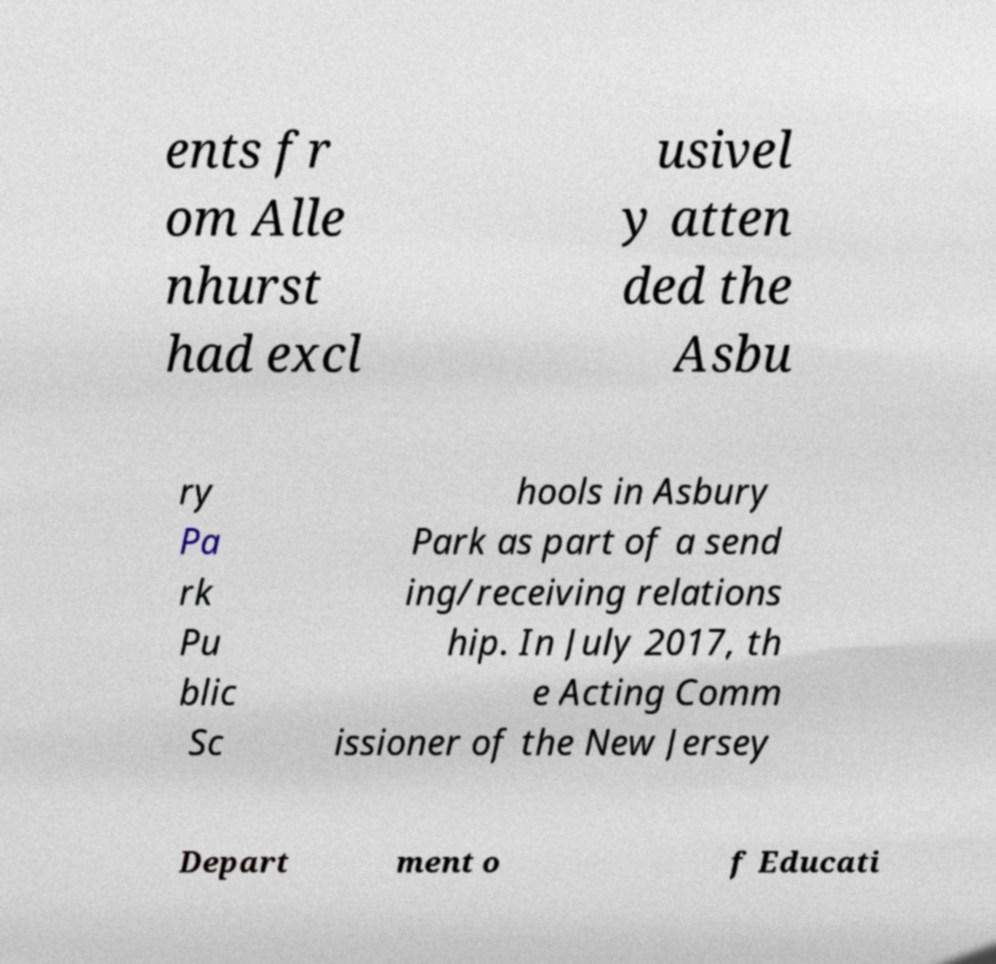Please identify and transcribe the text found in this image. ents fr om Alle nhurst had excl usivel y atten ded the Asbu ry Pa rk Pu blic Sc hools in Asbury Park as part of a send ing/receiving relations hip. In July 2017, th e Acting Comm issioner of the New Jersey Depart ment o f Educati 